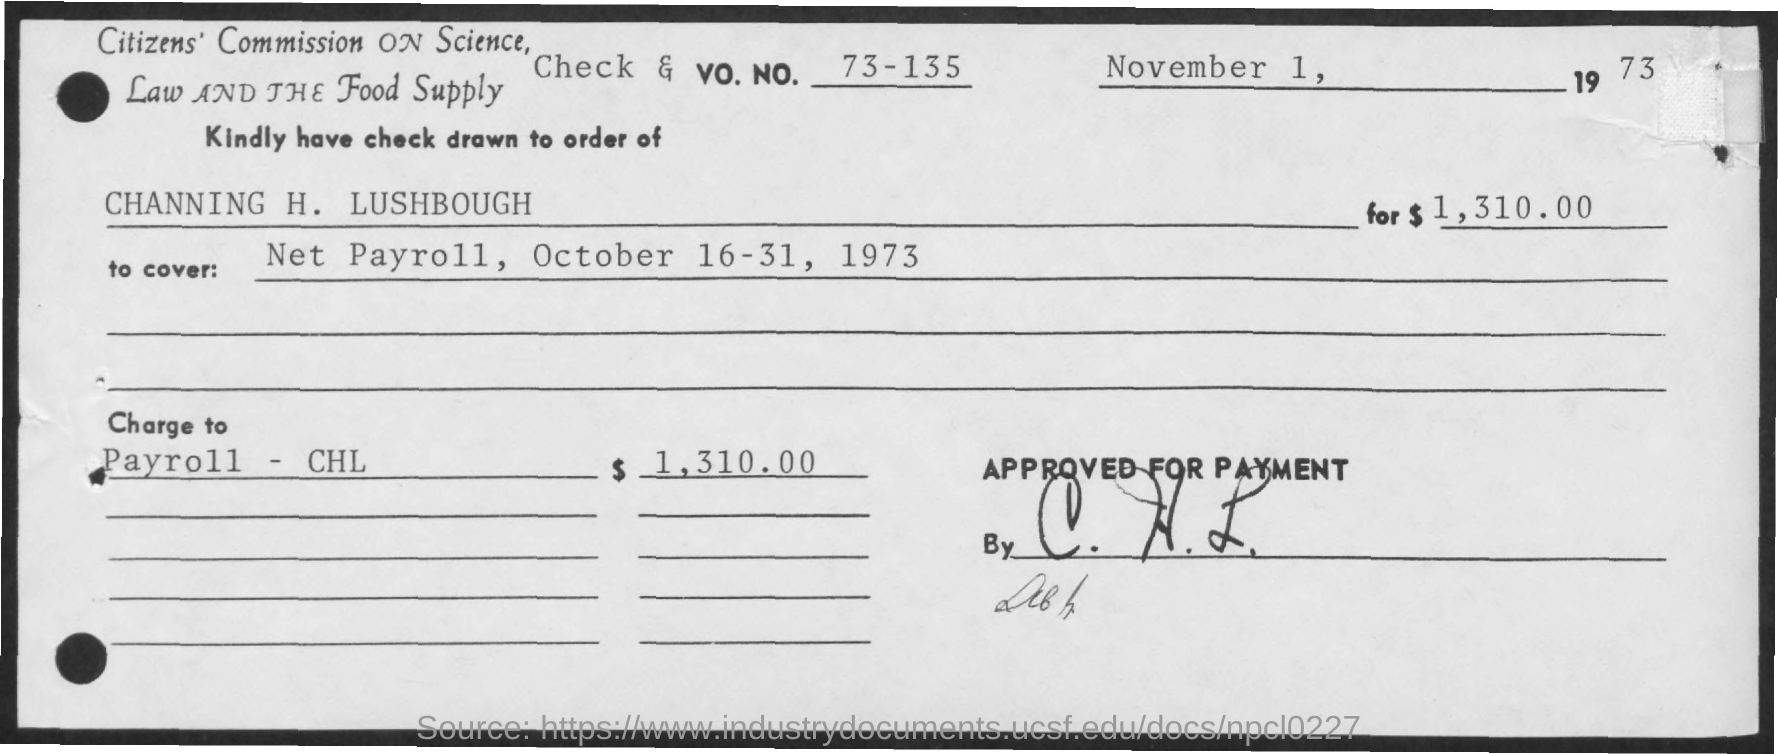What is the amount?
Provide a short and direct response. $1,310.00. What is date?
Keep it short and to the point. November 1, 1973. 